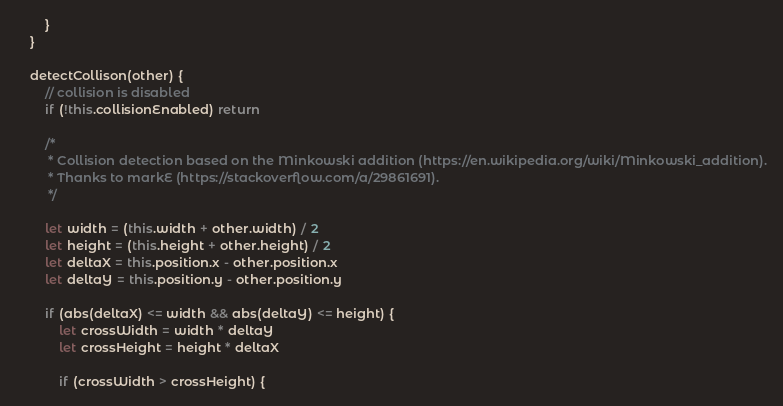<code> <loc_0><loc_0><loc_500><loc_500><_JavaScript_>        }
    }

    detectCollison(other) {
        // collision is disabled
        if (!this.collisionEnabled) return

        /*
         * Collision detection based on the Minkowski addition (https://en.wikipedia.org/wiki/Minkowski_addition).
         * Thanks to markE (https://stackoverflow.com/a/29861691).
         */

        let width = (this.width + other.width) / 2
        let height = (this.height + other.height) / 2
        let deltaX = this.position.x - other.position.x
        let deltaY = this.position.y - other.position.y

        if (abs(deltaX) <= width && abs(deltaY) <= height) {
            let crossWidth = width * deltaY
            let crossHeight = height * deltaX

            if (crossWidth > crossHeight) {</code> 